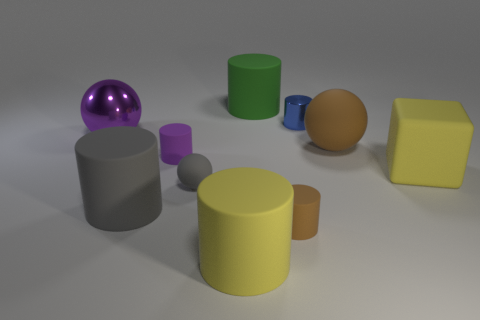Subtract all brown spheres. How many spheres are left? 2 Subtract all gray cylinders. How many cylinders are left? 5 Subtract 5 cylinders. How many cylinders are left? 1 Subtract all cubes. How many objects are left? 9 Add 2 large green metallic things. How many large green metallic things exist? 2 Subtract 0 red spheres. How many objects are left? 10 Subtract all green spheres. Subtract all cyan cylinders. How many spheres are left? 3 Subtract all small blue rubber cylinders. Subtract all tiny purple things. How many objects are left? 9 Add 8 large balls. How many large balls are left? 10 